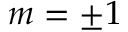Convert formula to latex. <formula><loc_0><loc_0><loc_500><loc_500>m = \pm 1</formula> 